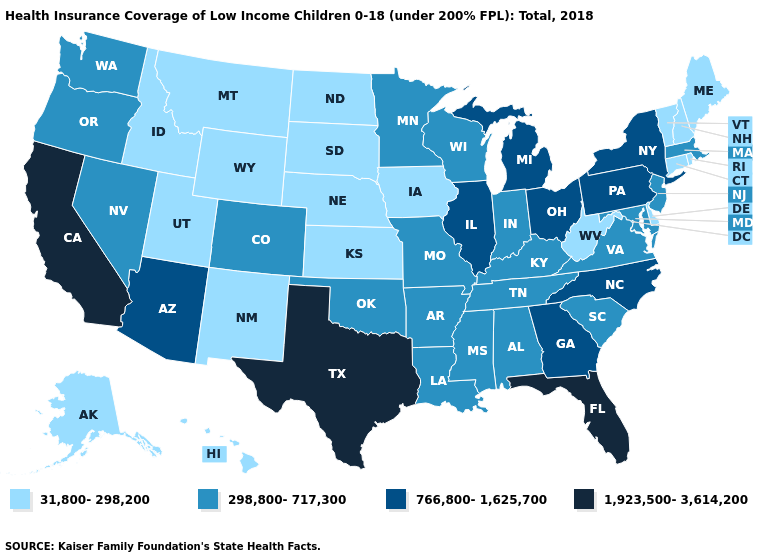Which states have the lowest value in the USA?
Concise answer only. Alaska, Connecticut, Delaware, Hawaii, Idaho, Iowa, Kansas, Maine, Montana, Nebraska, New Hampshire, New Mexico, North Dakota, Rhode Island, South Dakota, Utah, Vermont, West Virginia, Wyoming. Name the states that have a value in the range 31,800-298,200?
Short answer required. Alaska, Connecticut, Delaware, Hawaii, Idaho, Iowa, Kansas, Maine, Montana, Nebraska, New Hampshire, New Mexico, North Dakota, Rhode Island, South Dakota, Utah, Vermont, West Virginia, Wyoming. What is the value of Rhode Island?
Give a very brief answer. 31,800-298,200. Does Alaska have the highest value in the West?
Give a very brief answer. No. Among the states that border Tennessee , does Arkansas have the highest value?
Keep it brief. No. What is the highest value in states that border Texas?
Be succinct. 298,800-717,300. Is the legend a continuous bar?
Quick response, please. No. What is the value of Alaska?
Answer briefly. 31,800-298,200. Is the legend a continuous bar?
Give a very brief answer. No. What is the value of Georgia?
Quick response, please. 766,800-1,625,700. Which states hav the highest value in the South?
Be succinct. Florida, Texas. Which states have the highest value in the USA?
Keep it brief. California, Florida, Texas. Among the states that border Michigan , which have the lowest value?
Be succinct. Indiana, Wisconsin. What is the value of Wyoming?
Give a very brief answer. 31,800-298,200. Among the states that border Montana , which have the highest value?
Answer briefly. Idaho, North Dakota, South Dakota, Wyoming. 